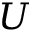<formula> <loc_0><loc_0><loc_500><loc_500>U</formula> 